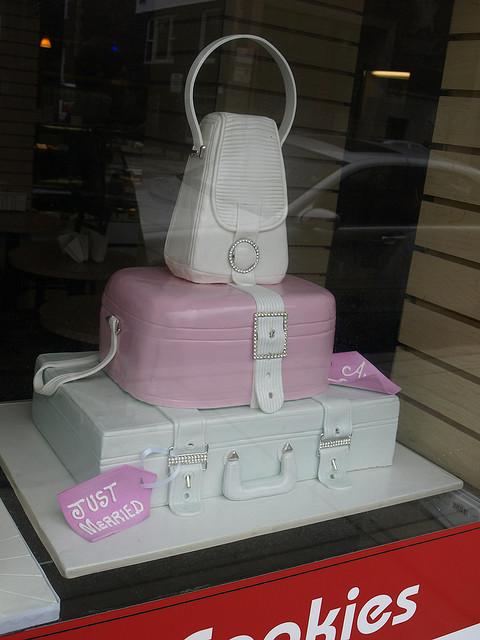How many dolls are on this cake?
Give a very brief answer. 0. What ceremony does the cake commemorate?
Be succinct. Wedding. What is sitting on top of the cake?
Quick response, please. Purse. What kind of cake is this?
Answer briefly. Wedding. What color are the trim and bows?
Answer briefly. White. What are the pink pieces of paper called?
Concise answer only. Tags. Is this cake made with fondant?
Give a very brief answer. Yes. Is this a child's cake?
Quick response, please. No. How many colors are the three pieces of luggage?
Answer briefly. 2. 